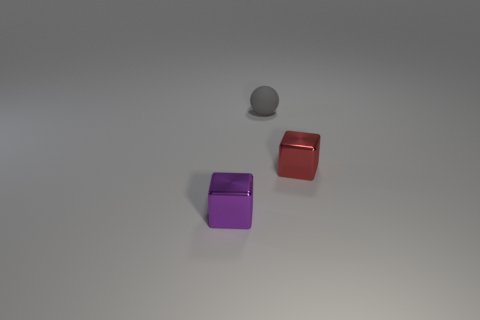Add 2 purple objects. How many objects exist? 5 Subtract all spheres. How many objects are left? 2 Subtract 0 yellow cylinders. How many objects are left? 3 Subtract all gray matte objects. Subtract all matte objects. How many objects are left? 1 Add 3 gray objects. How many gray objects are left? 4 Add 2 tiny red cubes. How many tiny red cubes exist? 3 